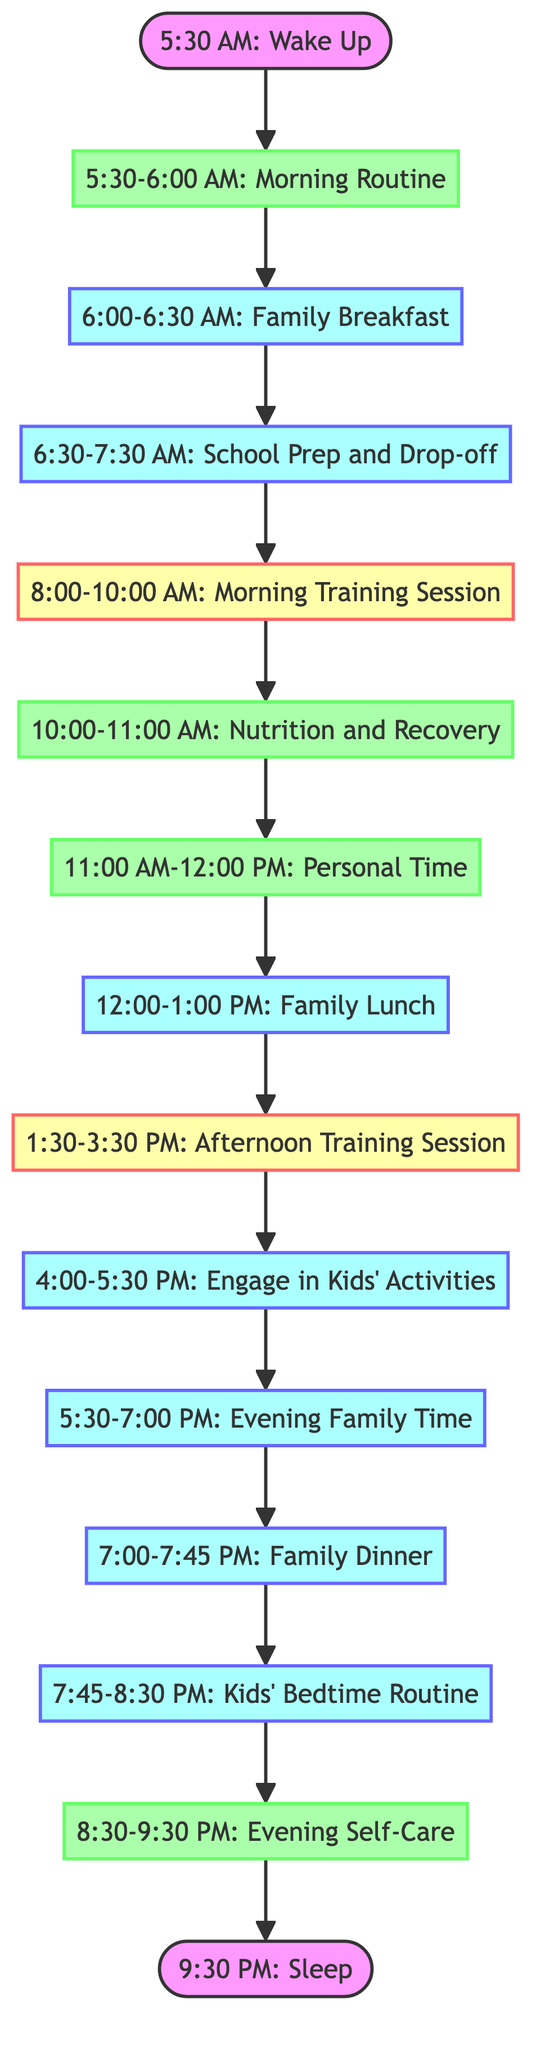What is the first activity of the day? The first activity listed in the diagram is "Wake Up," which occurs at 5:30 AM.
Answer: Wake Up How long is the Morning Routine? The Morning Routine is scheduled from 5:30 AM to 6:00 AM, which is a 30-minute duration.
Answer: 30 minutes What activity follows Family Breakfast? After Family Breakfast, the next activity is "School Prep and Drop-off."
Answer: School Prep and Drop-off How many hours are dedicated to training sessions? There is a Morning Training Session from 8:00 AM to 10:00 AM and an Afternoon Training Session from 1:30 PM to 3:30 PM, totaling 4 hours.
Answer: 4 hours What time does Family Dinner occur? Family Dinner is scheduled for 7:00 PM to 7:45 PM, which ends at 7:45 PM.
Answer: 7:00 PM Which activities are labeled as self-care? The activities labeled as self-care are "Morning Routine," "Nutrition and Recovery," "Personal Time," and "Evening Self-Care."
Answer: Morning Routine, Nutrition and Recovery, Personal Time, Evening Self-Care What is the last activity of the day? The last activity listed in the diagram is "Sleep," which starts at 9:30 PM.
Answer: Sleep What is the total time allocated for family interactions? Family interactions include Family Breakfast, Family Lunch, Evening Family Time, Family Dinner, and Kids' Bedtime Routine, totaling 4 hours and 15 minutes.
Answer: 4 hours and 15 minutes Which training session is first in the day? The first training session of the day is the "Morning Training Session."
Answer: Morning Training Session 